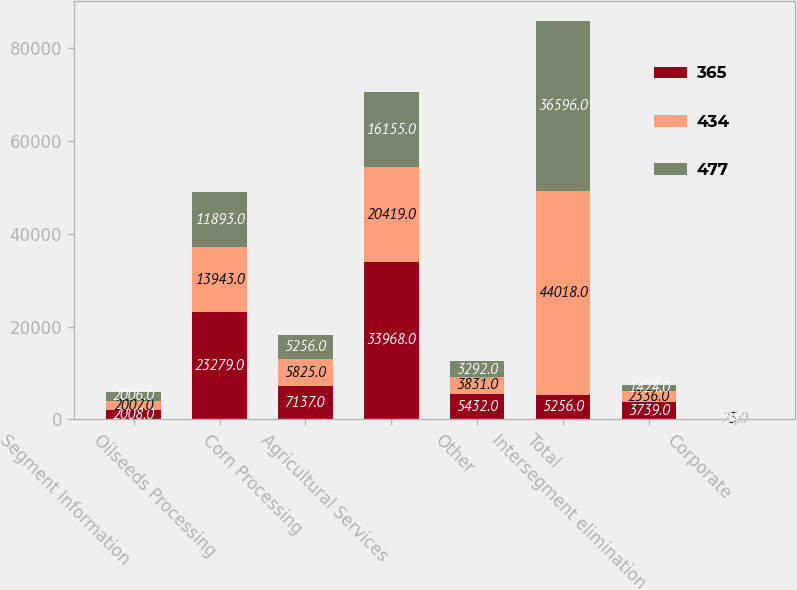Convert chart to OTSL. <chart><loc_0><loc_0><loc_500><loc_500><stacked_bar_chart><ecel><fcel>Segment Information<fcel>Oilseeds Processing<fcel>Corn Processing<fcel>Agricultural Services<fcel>Other<fcel>Total<fcel>Intersegment elimination<fcel>Corporate<nl><fcel>365<fcel>2008<fcel>23279<fcel>7137<fcel>33968<fcel>5432<fcel>5256<fcel>3739<fcel>20<nl><fcel>434<fcel>2007<fcel>13943<fcel>5825<fcel>20419<fcel>3831<fcel>44018<fcel>2336<fcel>23<nl><fcel>477<fcel>2006<fcel>11893<fcel>5256<fcel>16155<fcel>3292<fcel>36596<fcel>1424<fcel>24<nl></chart> 